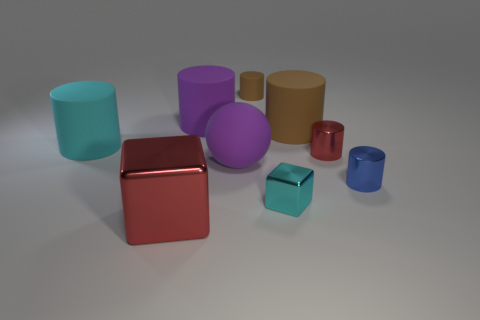Subtract all purple cylinders. How many cylinders are left? 5 Subtract all large purple matte cylinders. How many cylinders are left? 5 Subtract all purple cylinders. Subtract all red cubes. How many cylinders are left? 5 Add 1 small brown rubber blocks. How many objects exist? 10 Subtract all cylinders. How many objects are left? 3 Subtract all tiny red cylinders. Subtract all tiny red cylinders. How many objects are left? 7 Add 9 tiny rubber things. How many tiny rubber things are left? 10 Add 4 blue objects. How many blue objects exist? 5 Subtract 1 red cylinders. How many objects are left? 8 